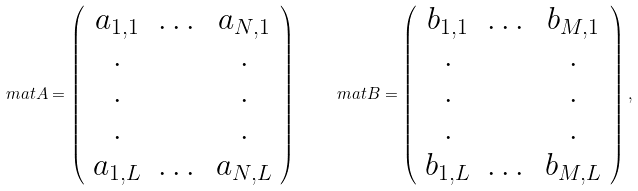<formula> <loc_0><loc_0><loc_500><loc_500>\ m a t { A } = \left ( \begin{array} { c c c } a _ { 1 , 1 } & \dots & a _ { N , 1 } \\ . & & . \\ . & & . \\ . & & . \\ a _ { 1 , L } & \dots & a _ { N , L } \end{array} \right ) \quad \ m a t { B } = \left ( \begin{array} { c c c } b _ { 1 , 1 } & \dots & b _ { M , 1 } \\ . & & . \\ . & & . \\ . & & . \\ b _ { 1 , L } & \dots & b _ { M , L } \end{array} \right ) ,</formula> 